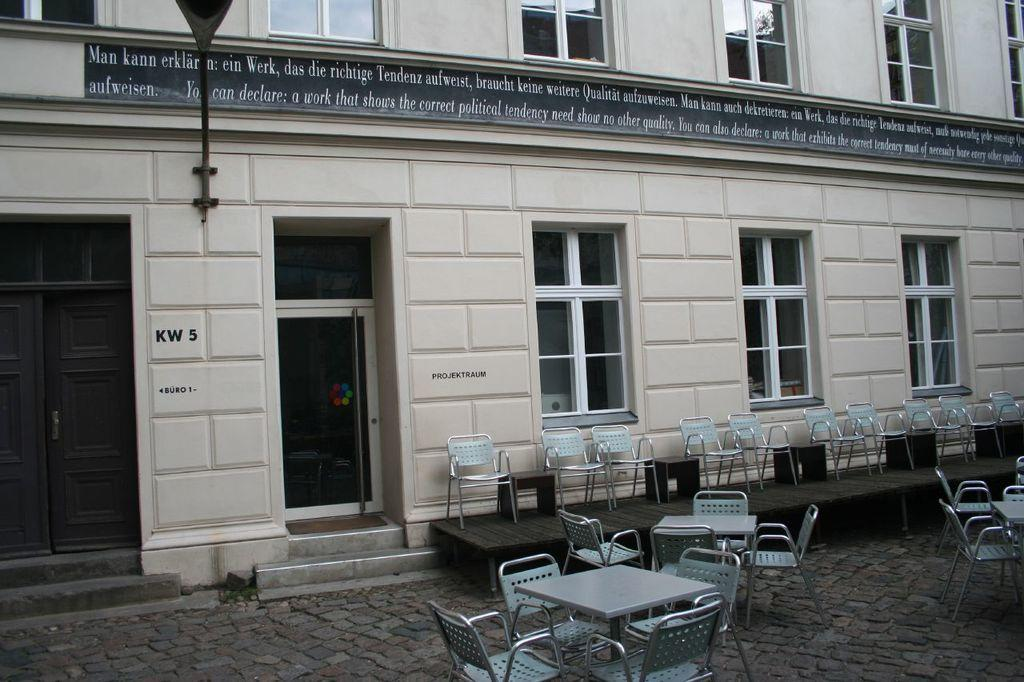What type of furniture is present in the image? There are chairs, tables, and stools in the image. What is the primary purpose of the furniture in the image? The furniture is likely for seating and dining, as there are chairs, tables, and stools. What is the main feature of the room in the image? There is a stage in the image, which suggests that the room is used for performances or events. What can be seen in the background of the image? There are windows and a light visible in the background of the image. What type of cheese is being served on the tables in the image? There is no cheese present in the image; the tables are empty. What brand of toothpaste is advertised on the stage in the image? There is no toothpaste or advertisement present in the image; the stage is empty. 